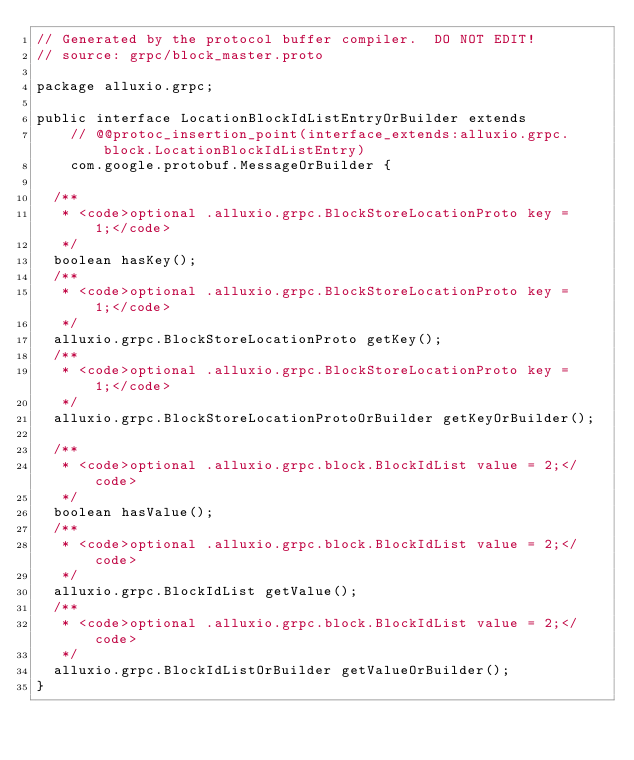Convert code to text. <code><loc_0><loc_0><loc_500><loc_500><_Java_>// Generated by the protocol buffer compiler.  DO NOT EDIT!
// source: grpc/block_master.proto

package alluxio.grpc;

public interface LocationBlockIdListEntryOrBuilder extends
    // @@protoc_insertion_point(interface_extends:alluxio.grpc.block.LocationBlockIdListEntry)
    com.google.protobuf.MessageOrBuilder {

  /**
   * <code>optional .alluxio.grpc.BlockStoreLocationProto key = 1;</code>
   */
  boolean hasKey();
  /**
   * <code>optional .alluxio.grpc.BlockStoreLocationProto key = 1;</code>
   */
  alluxio.grpc.BlockStoreLocationProto getKey();
  /**
   * <code>optional .alluxio.grpc.BlockStoreLocationProto key = 1;</code>
   */
  alluxio.grpc.BlockStoreLocationProtoOrBuilder getKeyOrBuilder();

  /**
   * <code>optional .alluxio.grpc.block.BlockIdList value = 2;</code>
   */
  boolean hasValue();
  /**
   * <code>optional .alluxio.grpc.block.BlockIdList value = 2;</code>
   */
  alluxio.grpc.BlockIdList getValue();
  /**
   * <code>optional .alluxio.grpc.block.BlockIdList value = 2;</code>
   */
  alluxio.grpc.BlockIdListOrBuilder getValueOrBuilder();
}
</code> 